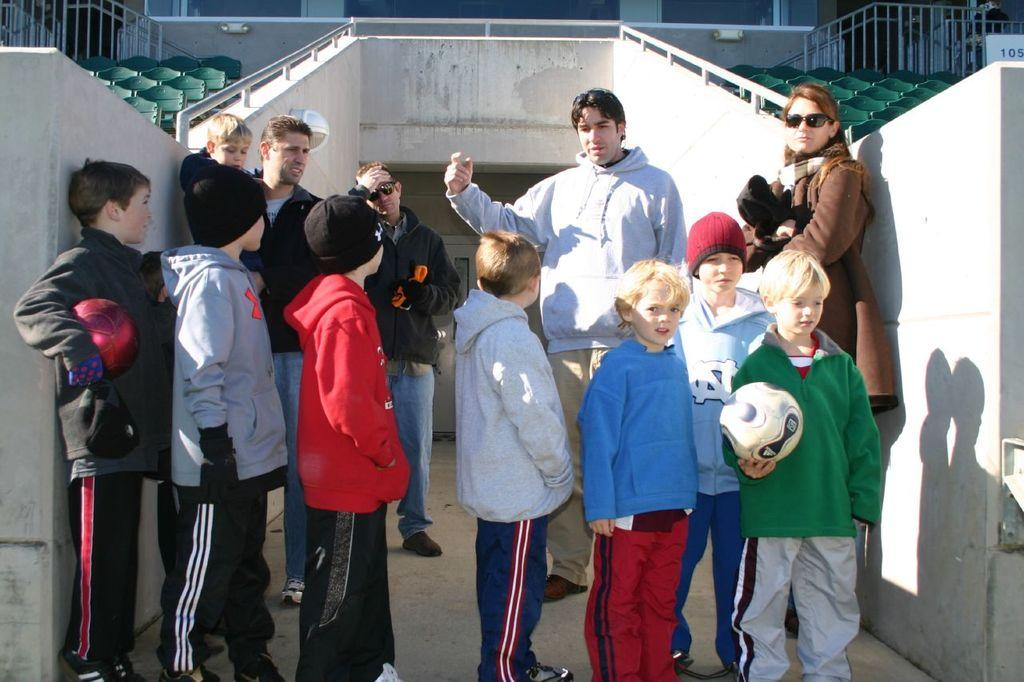Who is present in the image? There are children in the image. What is the boy on the right side of the image holding? The boy is holding a ball on the right side of the image. Where are the seats located in the image? There are seats on both the left and right sides of the image. What type of brush is being used to maintain the children's health in the image? There is no brush or reference to health maintenance in the image; it simply shows children, a boy holding a ball, and seats on both sides. 